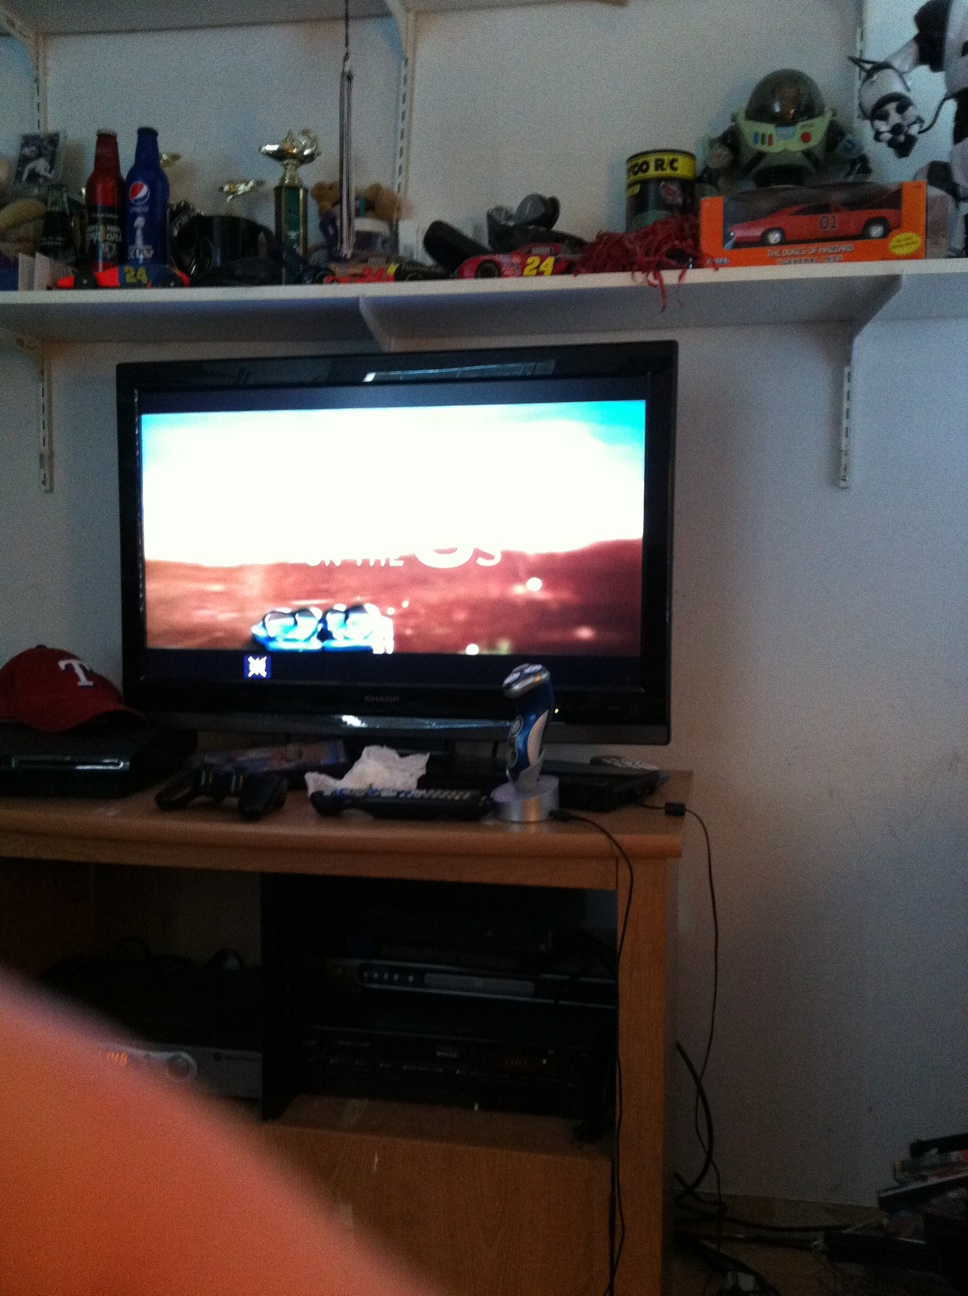Create a story involving the objects in the room. Once upon a time in this cozy room, the toy cars on the shelf above the TV came to life when no one was watching. They would race around, exploring the room while the TV showed exciting adventures that fueled their imaginations. The aliens and space ranger figures stood guard, keeping an eye out for any signs of trouble. Meanwhile, the trophies gleamed with pride, telling silent stories of past victories. Every night was a new adventure, filled with races, explorations, and heroic deeds. 